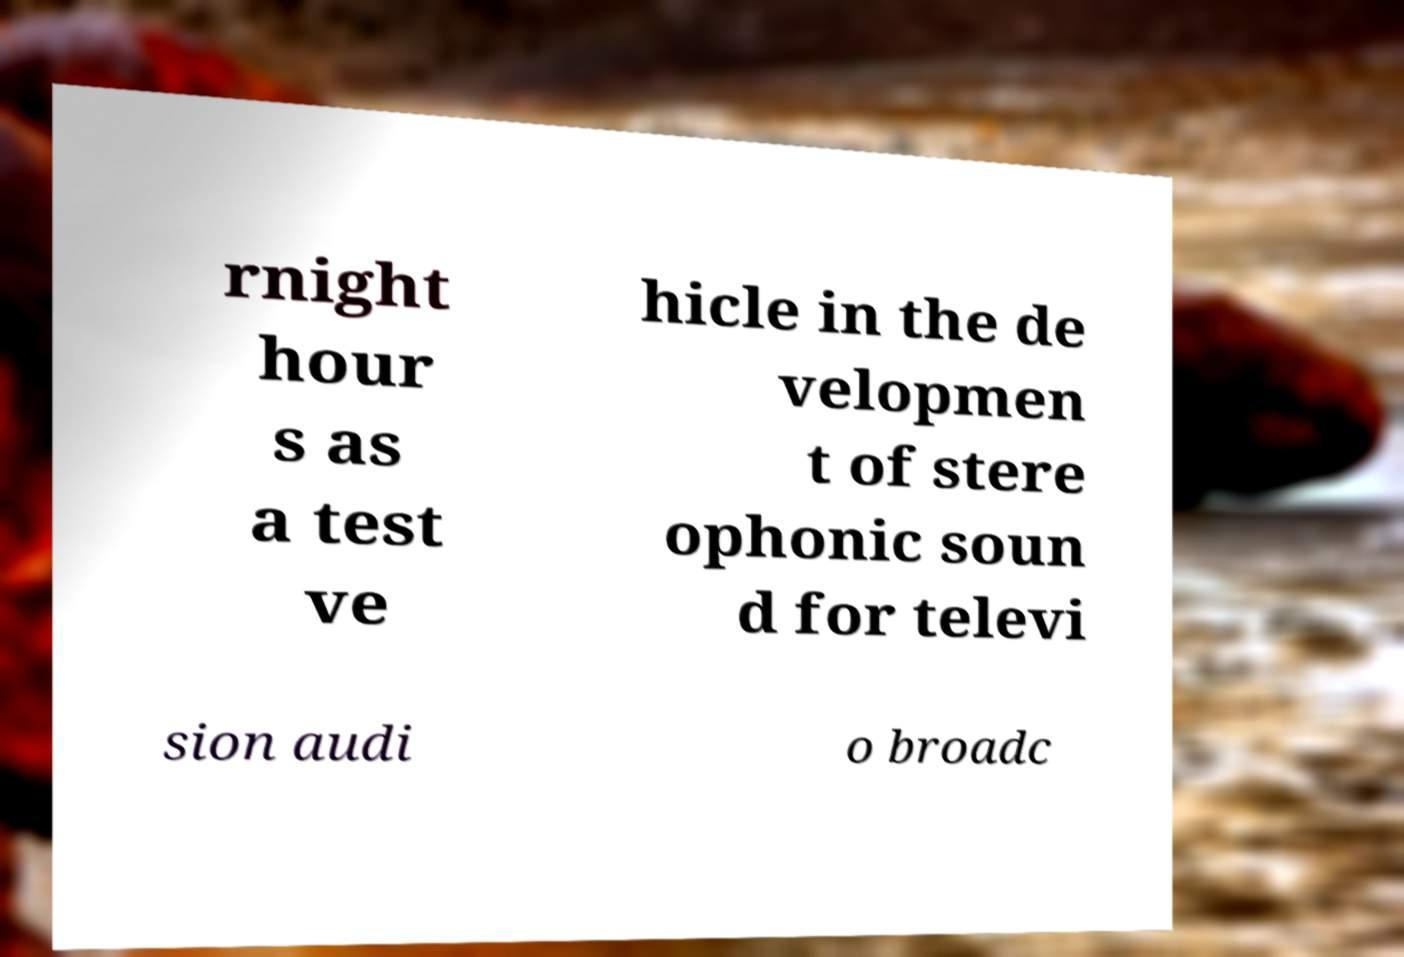Please read and relay the text visible in this image. What does it say? rnight hour s as a test ve hicle in the de velopmen t of stere ophonic soun d for televi sion audi o broadc 